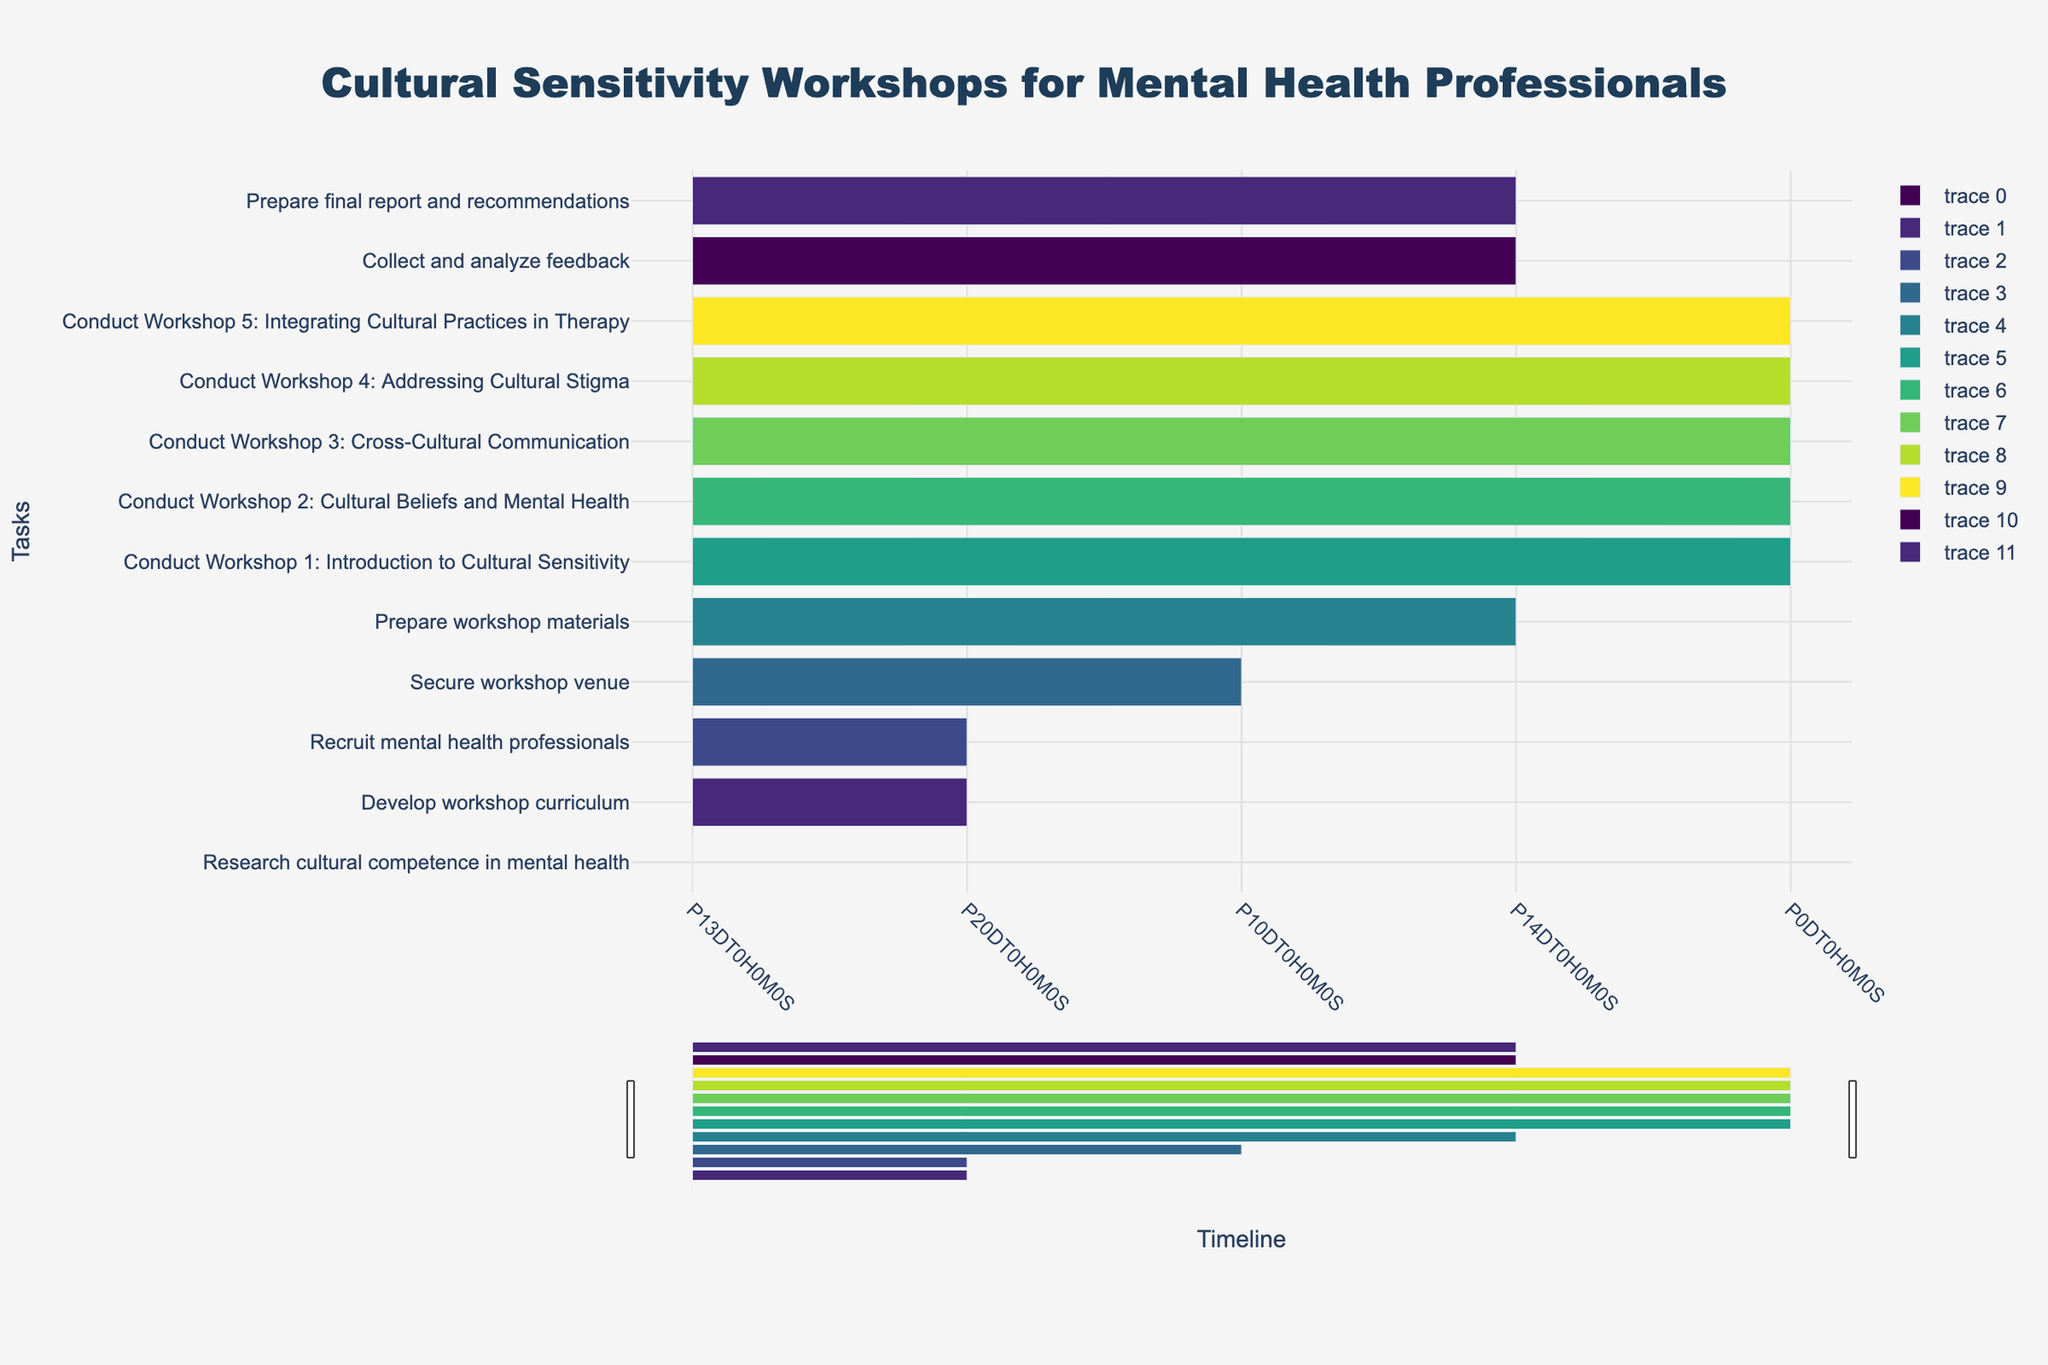how many tasks are displayed in the Gantt chart? Examine the Gantt chart and count the number of distinct task bars displayed on the chart. Each task represents a unique activity.
Answer: 12 What is the title of the Gantt chart? Look at the top of the Gantt chart where the title is typically displayed. The title should provide a summary of what the chart represents.
Answer: Cultural Sensitivity Workshops for Mental Health Professionals Which task has the shortest duration? Compare the durations of all tasks displayed on the Gantt chart and identify the one with the shortest bar. The task's duration can also be found in the hovertext information.
Answer: Conduct Workshop 1: Introduction to Cultural Sensitivity How many days does the task "Secure workshop venue" take? Refer to the Gantt chart and locate the task "Secure workshop venue". Check the duration displayed either on the bar itself or in the hovertext.
Answer: 11 days Which tasks overlap in October 2023? Identify the tasks that have overlapping bars in the month of October by looking at the timeline and the positions of the task bars within that month.
Answer: Develop workshop curriculum, Recruit mental health professionals, Secure workshop venue What is the total duration (in days) from the start of "Research cultural competence in mental health" to the end of "Prepare final report and recommendations"? Find the start date of "Research cultural competence in mental health" and the end date of "Prepare final report and recommendations". Calculate the total number of days between these two dates. Start Date: 2023-09-01, End Date: 2024-01-15. Total days: (2024-01-15 - 2023-09-01).
Answer: 137 days Which month has the highest number of tasks scheduled to be completed? Review each month on the Gantt chart and count the number of tasks that have their end dates in that month. Compare the counts to find the month with the highest number.
Answer: December 2023 Which task takes place entirely within one day? Look for tasks that have bars representing just one day in duration. The hovertext can also help identify single-day tasks by displaying duration information as "1 day".
Answer: Conduct Workshop 1: Introduction to Cultural Sensitivity, Conduct Workshop 2: Cultural Beliefs and Mental Health, Conduct Workshop 3: Cross-Cultural Communication, Conduct Workshop 4: Addressing Cultural Stigma, Conduct Workshop 5: Integrating Cultural Practices in Therapy How many tasks have a duration of more than 20 days? Examine the durations of all tasks displayed on the Gantt chart. Count the number of tasks with a duration greater than 20 days.
Answer: 2 tasks When does the task "Collect and analyze feedback" start and end? Locate the task "Collect and analyze feedback" on the Gantt chart and observe its start and end dates as displayed on the respective bar or in the hovertext.
Answer: Start: 2023-12-17, End: 2023-12-31 